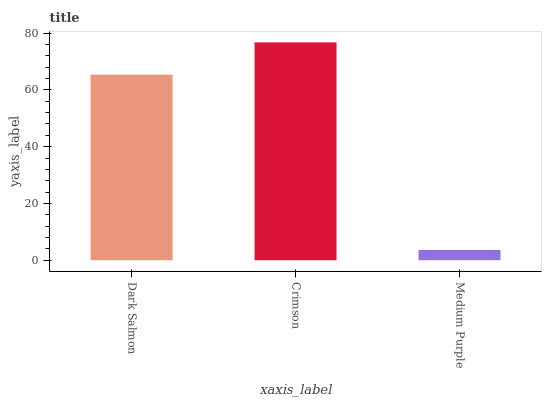Is Medium Purple the minimum?
Answer yes or no. Yes. Is Crimson the maximum?
Answer yes or no. Yes. Is Crimson the minimum?
Answer yes or no. No. Is Medium Purple the maximum?
Answer yes or no. No. Is Crimson greater than Medium Purple?
Answer yes or no. Yes. Is Medium Purple less than Crimson?
Answer yes or no. Yes. Is Medium Purple greater than Crimson?
Answer yes or no. No. Is Crimson less than Medium Purple?
Answer yes or no. No. Is Dark Salmon the high median?
Answer yes or no. Yes. Is Dark Salmon the low median?
Answer yes or no. Yes. Is Crimson the high median?
Answer yes or no. No. Is Crimson the low median?
Answer yes or no. No. 